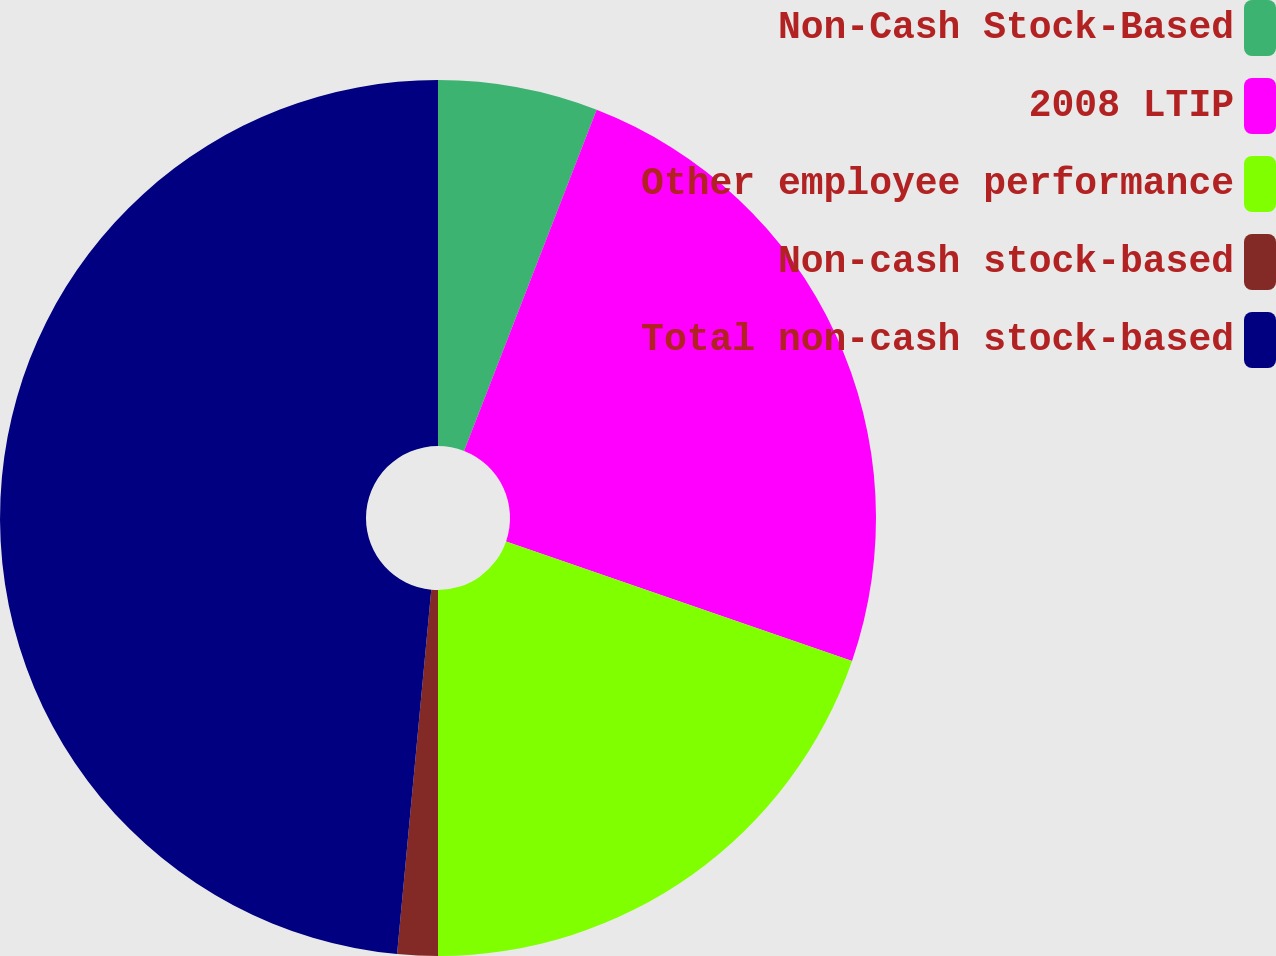Convert chart to OTSL. <chart><loc_0><loc_0><loc_500><loc_500><pie_chart><fcel>Non-Cash Stock-Based<fcel>2008 LTIP<fcel>Other employee performance<fcel>Non-cash stock-based<fcel>Total non-cash stock-based<nl><fcel>5.9%<fcel>24.39%<fcel>19.71%<fcel>1.49%<fcel>48.51%<nl></chart> 